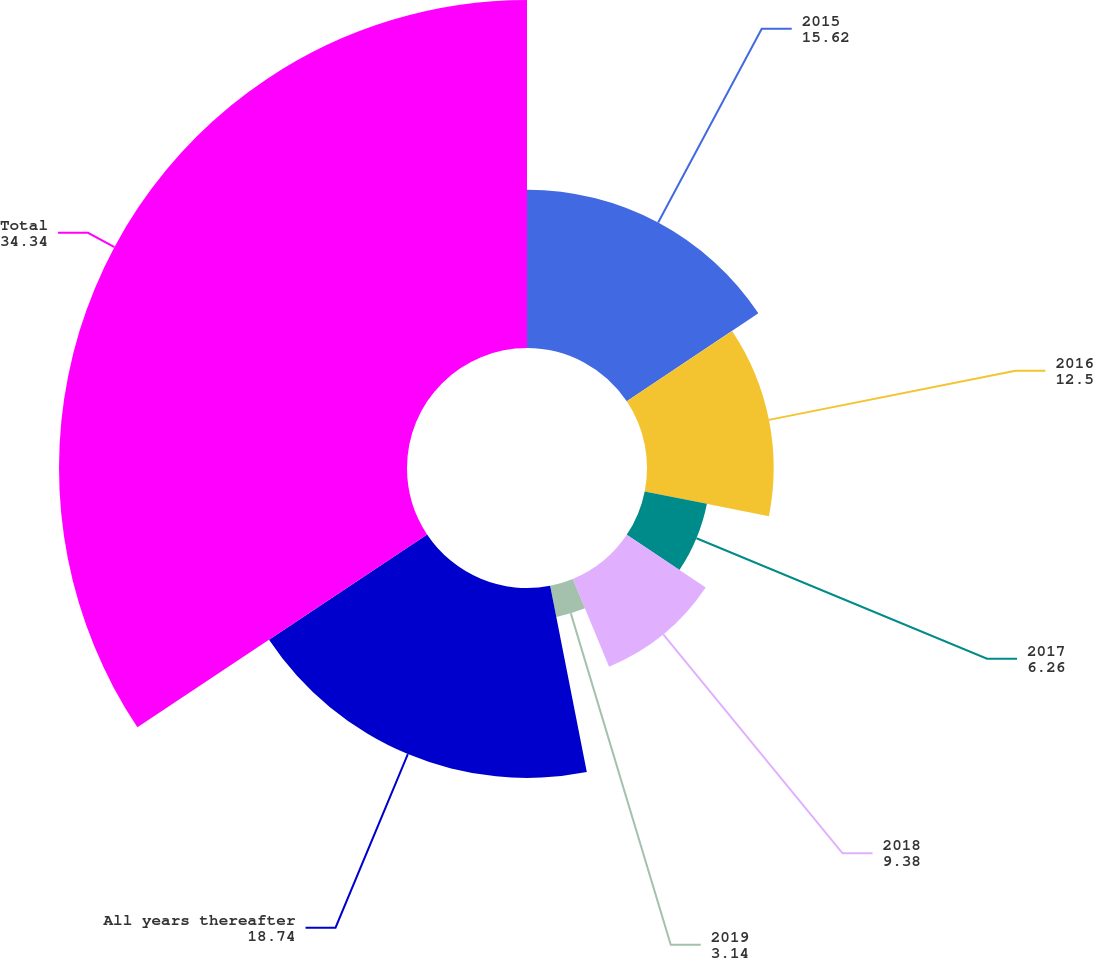Convert chart to OTSL. <chart><loc_0><loc_0><loc_500><loc_500><pie_chart><fcel>2015<fcel>2016<fcel>2017<fcel>2018<fcel>2019<fcel>All years thereafter<fcel>Total<nl><fcel>15.62%<fcel>12.5%<fcel>6.26%<fcel>9.38%<fcel>3.14%<fcel>18.74%<fcel>34.34%<nl></chart> 